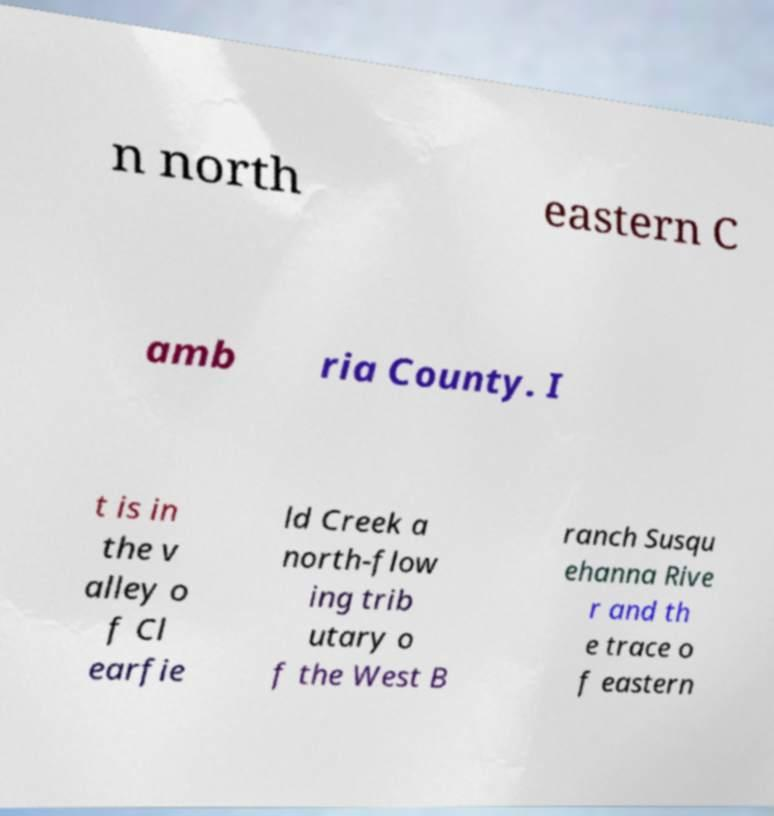Please identify and transcribe the text found in this image. n north eastern C amb ria County. I t is in the v alley o f Cl earfie ld Creek a north-flow ing trib utary o f the West B ranch Susqu ehanna Rive r and th e trace o f eastern 